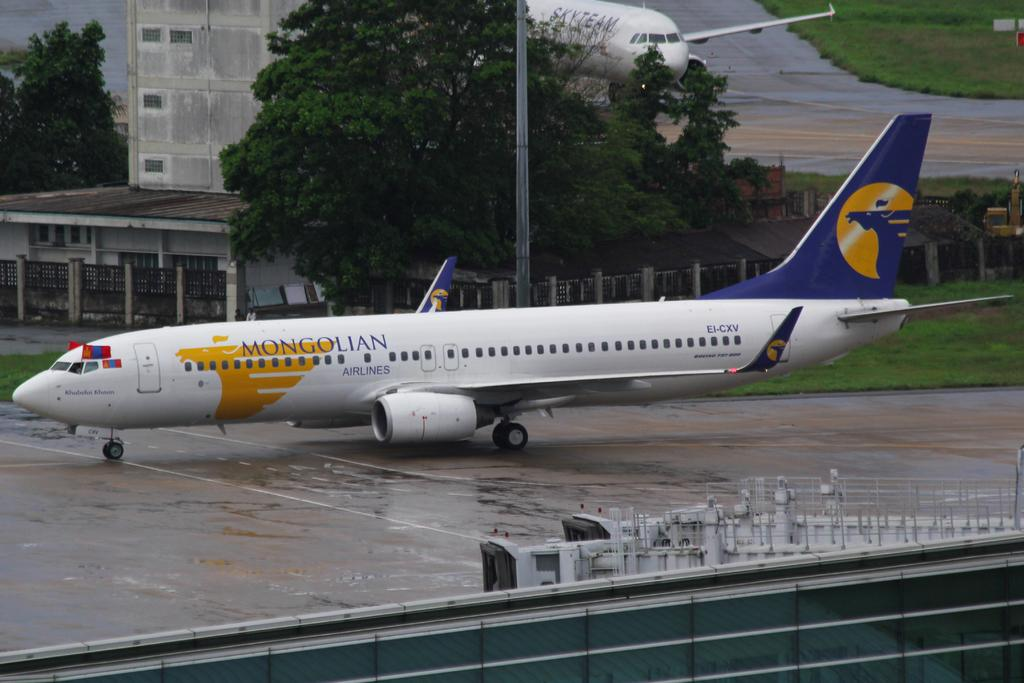<image>
Write a terse but informative summary of the picture. A Mongolian Airlines plane sits on the runway. 